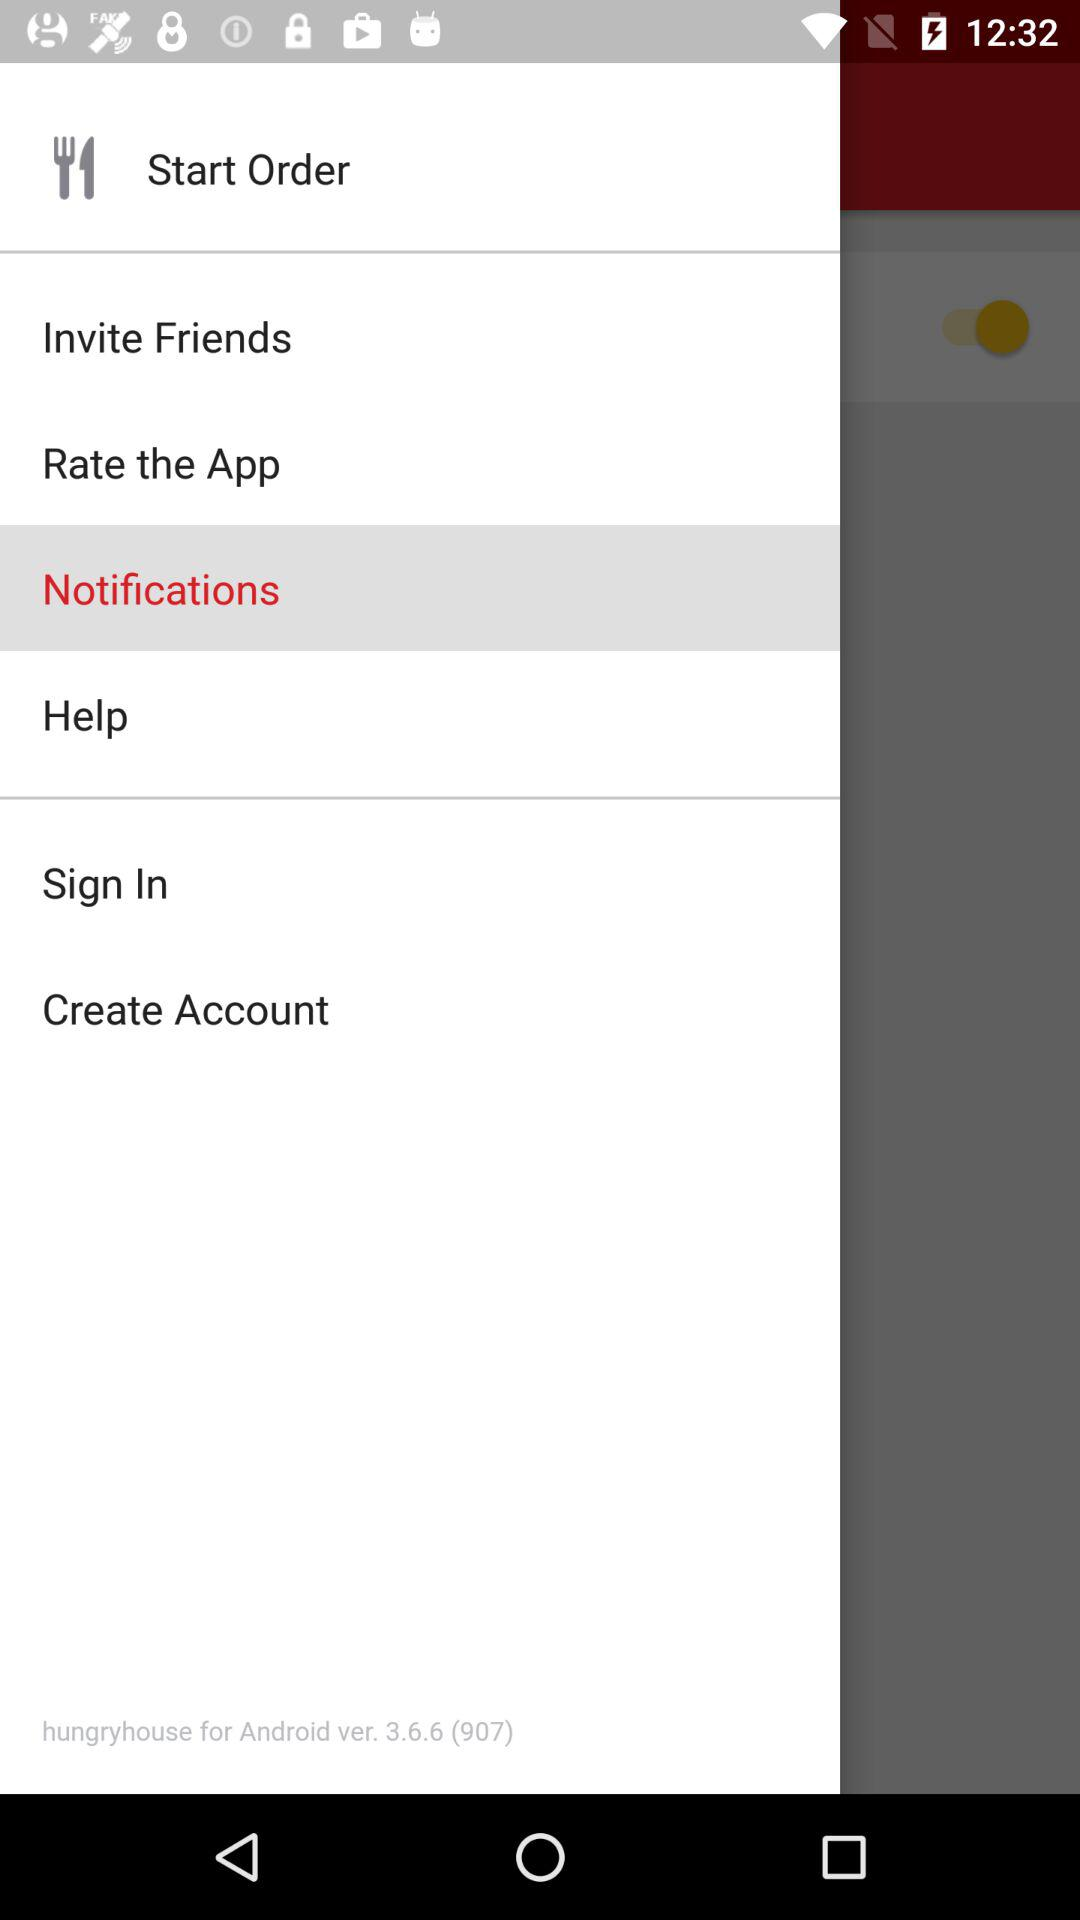What is the name of the application?
When the provided information is insufficient, respond with <no answer>. <no answer> 